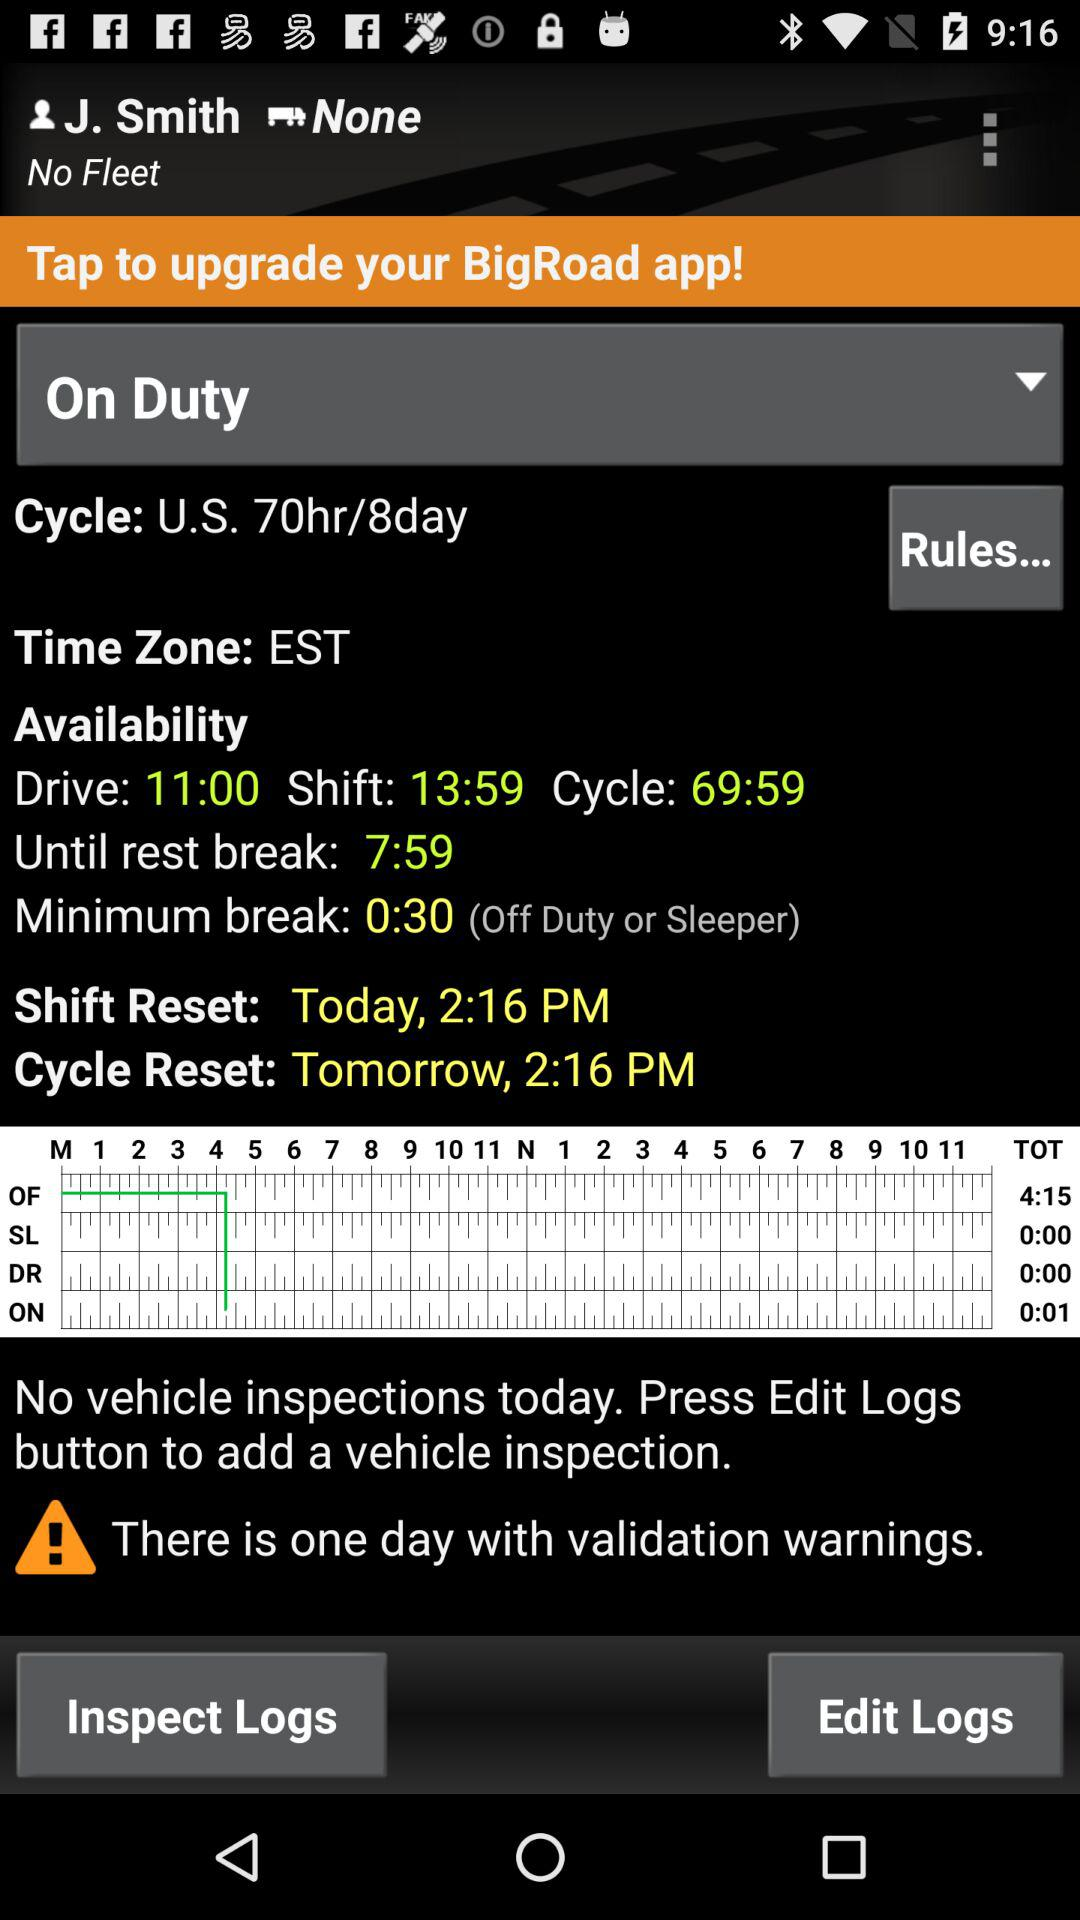What is the shift reset timing? The shift reset timing is 2:16 PM. 